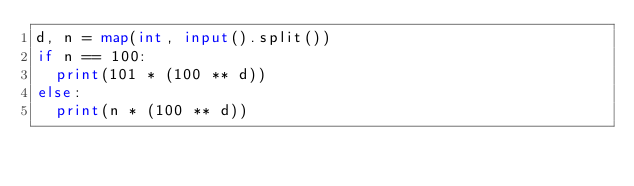<code> <loc_0><loc_0><loc_500><loc_500><_Python_>d, n = map(int, input().split())
if n == 100:
  print(101 * (100 ** d))
else:
  print(n * (100 ** d))
</code> 